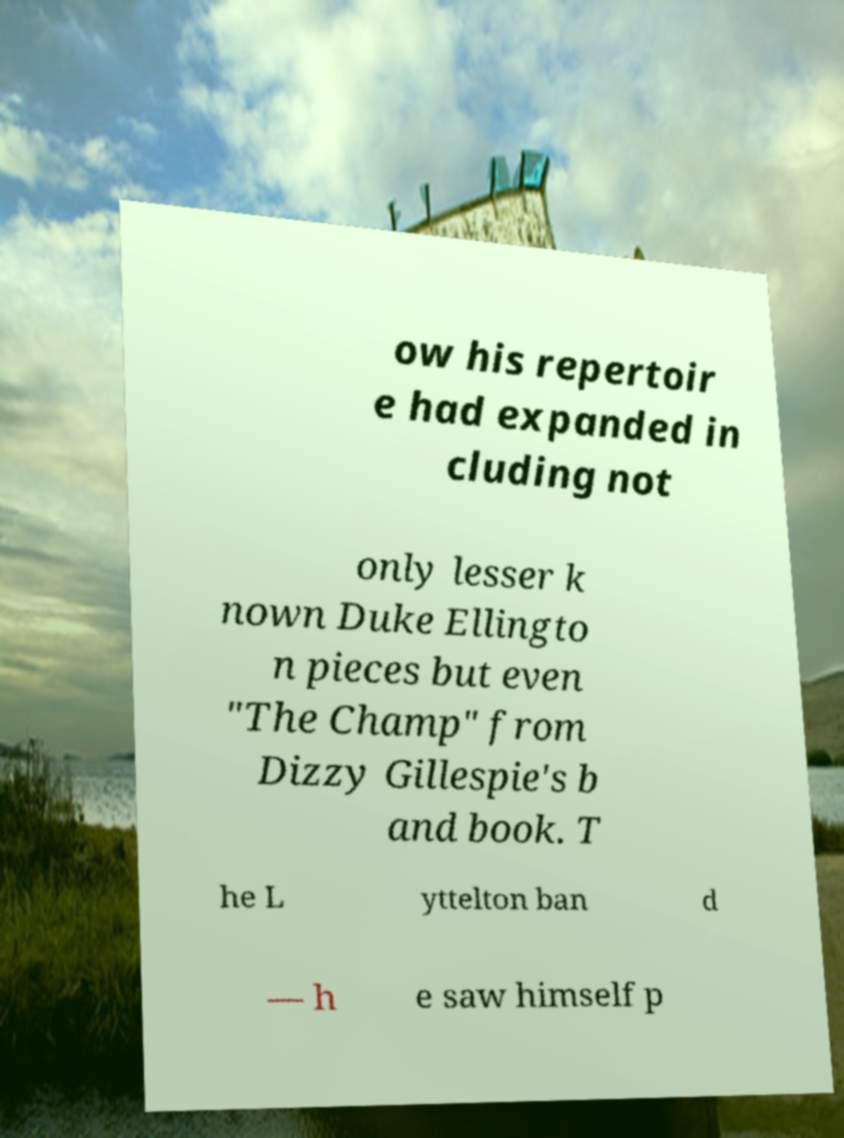There's text embedded in this image that I need extracted. Can you transcribe it verbatim? ow his repertoir e had expanded in cluding not only lesser k nown Duke Ellingto n pieces but even "The Champ" from Dizzy Gillespie's b and book. T he L yttelton ban d — h e saw himself p 